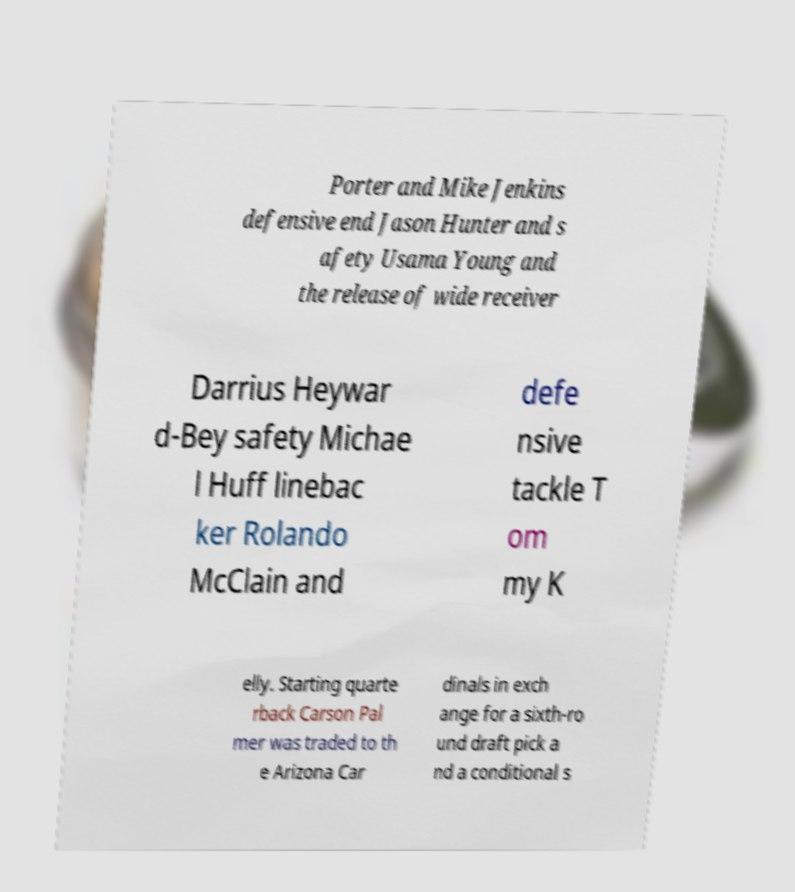Can you accurately transcribe the text from the provided image for me? Porter and Mike Jenkins defensive end Jason Hunter and s afety Usama Young and the release of wide receiver Darrius Heywar d-Bey safety Michae l Huff linebac ker Rolando McClain and defe nsive tackle T om my K elly. Starting quarte rback Carson Pal mer was traded to th e Arizona Car dinals in exch ange for a sixth-ro und draft pick a nd a conditional s 